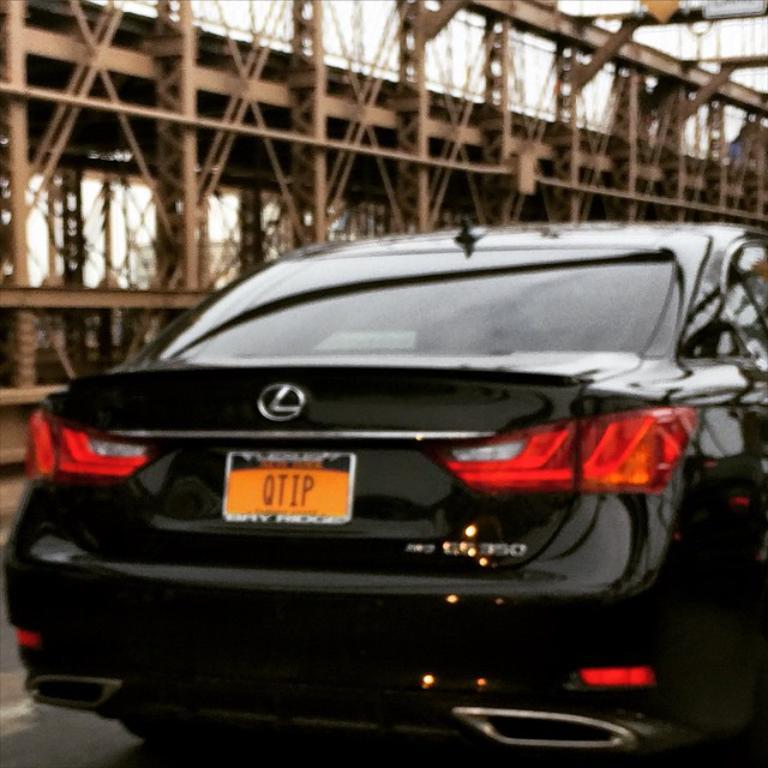What color is the car on the road in the image? The car on the road is black in color. What can be seen in the background of the image? There is a brown color bridge in the background. How would you describe the color of the sky in the image? The sky appears to be white in color. Are there any stockings hanging from the bridge in the image? There are no stockings visible in the image, as it only features a black color car on the road, a brown color bridge in the background, and a white color sky. 